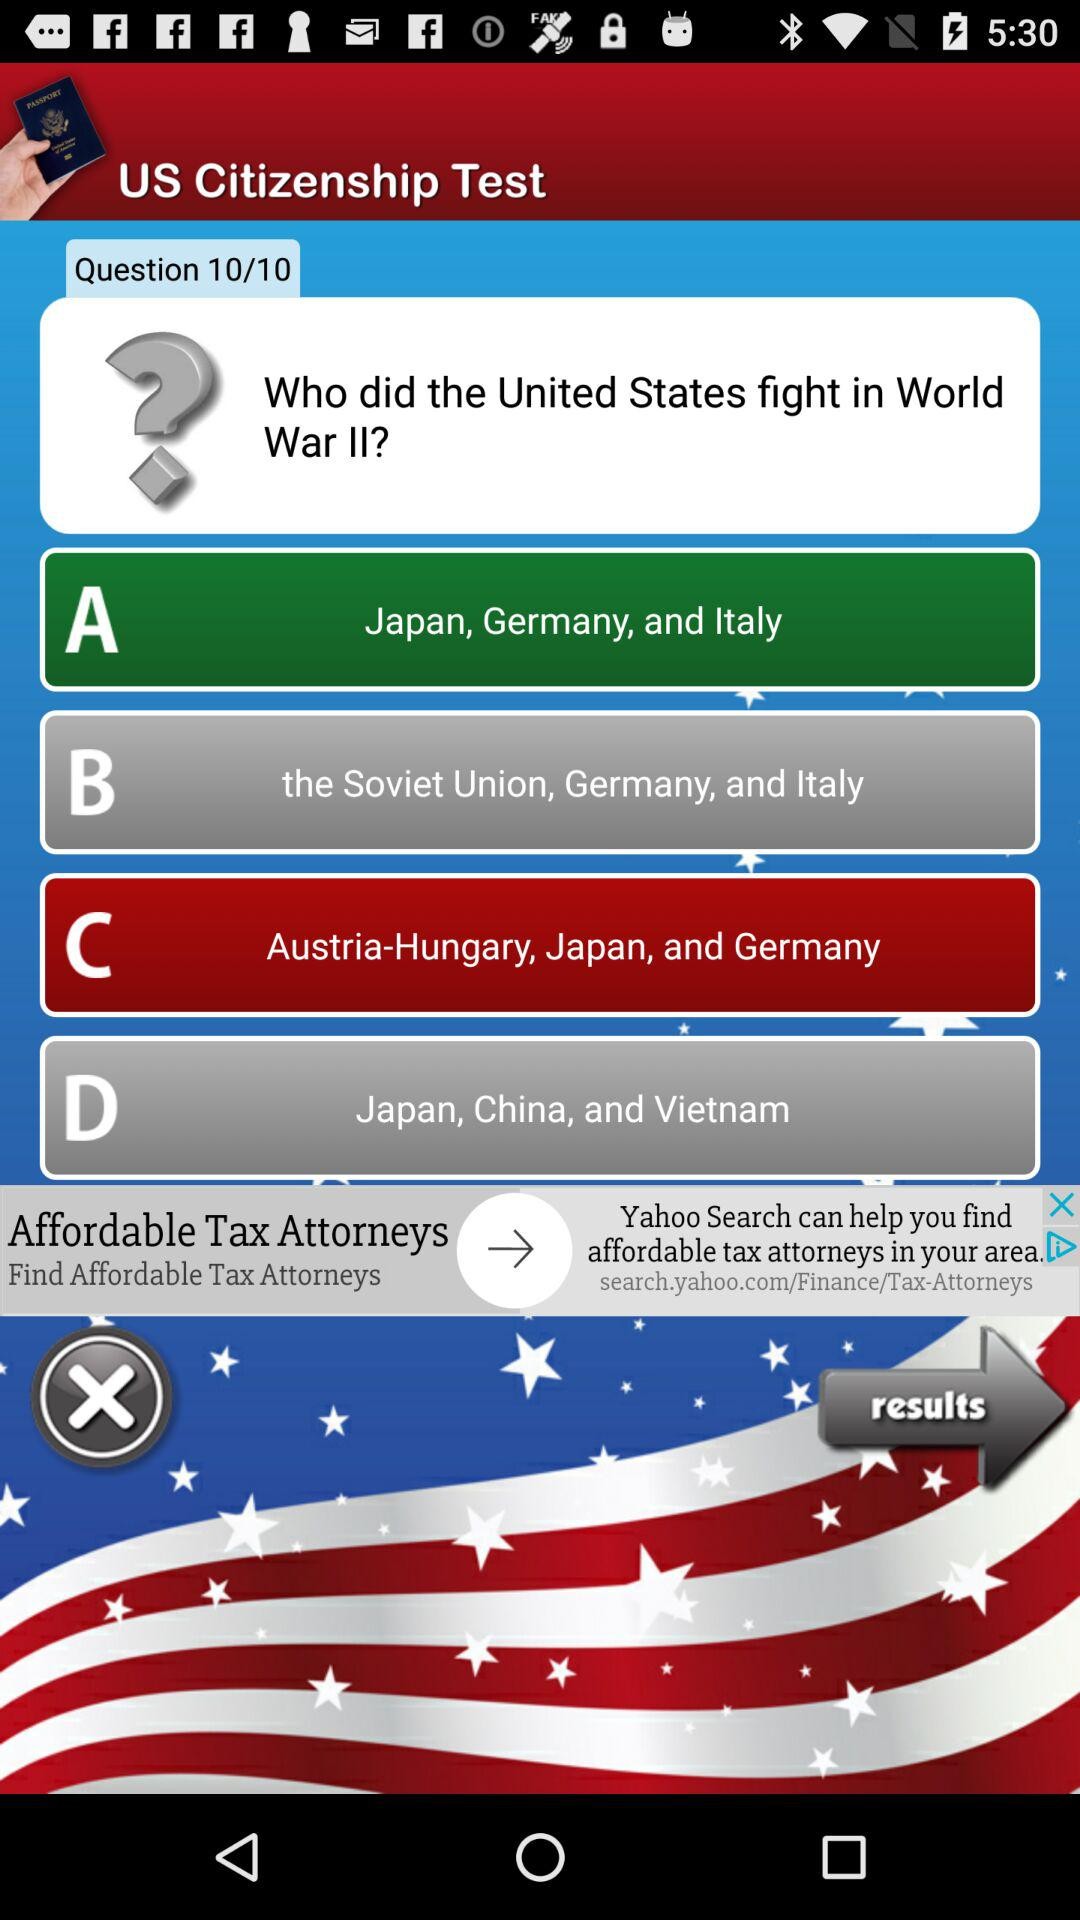How many questions in total are there in the test? There are 10 questions in the test. 